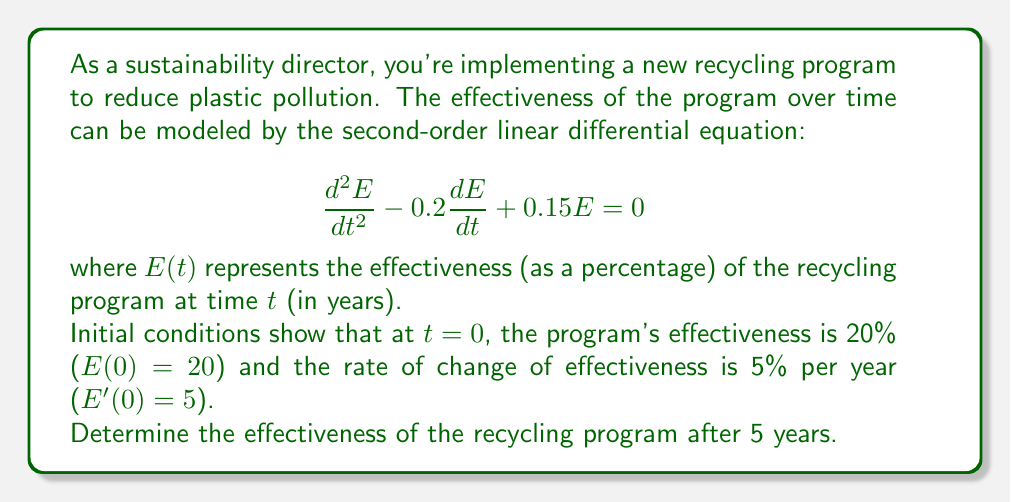Help me with this question. To solve this problem, we'll follow these steps:

1) First, we need to find the general solution of the differential equation. The characteristic equation is:
   $$r^2 - 0.2r + 0.15 = 0$$

2) Solving this equation:
   $$r = \frac{0.2 \pm \sqrt{0.2^2 - 4(0.15)}}{2} = \frac{0.2 \pm \sqrt{0.04 - 0.6}}{2} = \frac{0.2 \pm \sqrt{-0.56}}{2}$$

3) This gives us complex roots:
   $$r = 0.1 \pm 0.374i$$

4) The general solution is therefore:
   $$E(t) = e^{0.1t}(c_1\cos(0.374t) + c_2\sin(0.374t))$$

5) Now we use the initial conditions to find $c_1$ and $c_2$:
   $E(0) = 20$ gives us: $c_1 = 20$
   
   $E'(0) = 5$ gives us: $0.1c_1 + 0.374c_2 = 5$
   
   Substituting $c_1 = 20$: $2 + 0.374c_2 = 5$
   
   Solving for $c_2$: $c_2 = 8.02$

6) Our particular solution is:
   $$E(t) = e^{0.1t}(20\cos(0.374t) + 8.02\sin(0.374t))$$

7) To find the effectiveness after 5 years, we substitute $t = 5$:
   $$E(5) = e^{0.5}(20\cos(1.87) + 8.02\sin(1.87))$$

8) Calculating this:
   $$E(5) \approx 1.649 * (-3.78 + 7.68) \approx 6.42$$
Answer: 6.42% 